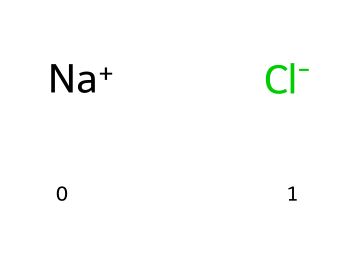What are the two ions present in this electrolyte? The chemical structure shows sodium (Na+) and chloride (Cl-) ions. These represent the components of the electrolyte.
Answer: sodium and chloride How many atoms are in this electrolyte? The chemical consists of one sodium atom and one chlorine atom, totaling two atoms.
Answer: two What is the charge of sodium in this electrolytic structure? The sodium ion is specified as Na+, indicating that it carries a positive charge.
Answer: positive Is this electrolyte ionic or covalent? The presence of charged ions (Na+ and Cl-) signifies that this compound is ionic in nature.
Answer: ionic What role does chloride play in the body when consuming this electrolyte? Chloride ions are essential for maintaining fluid balance and are involved in nerve signal transmission, making them vital when consumed in electrolytes.
Answer: fluid balance 